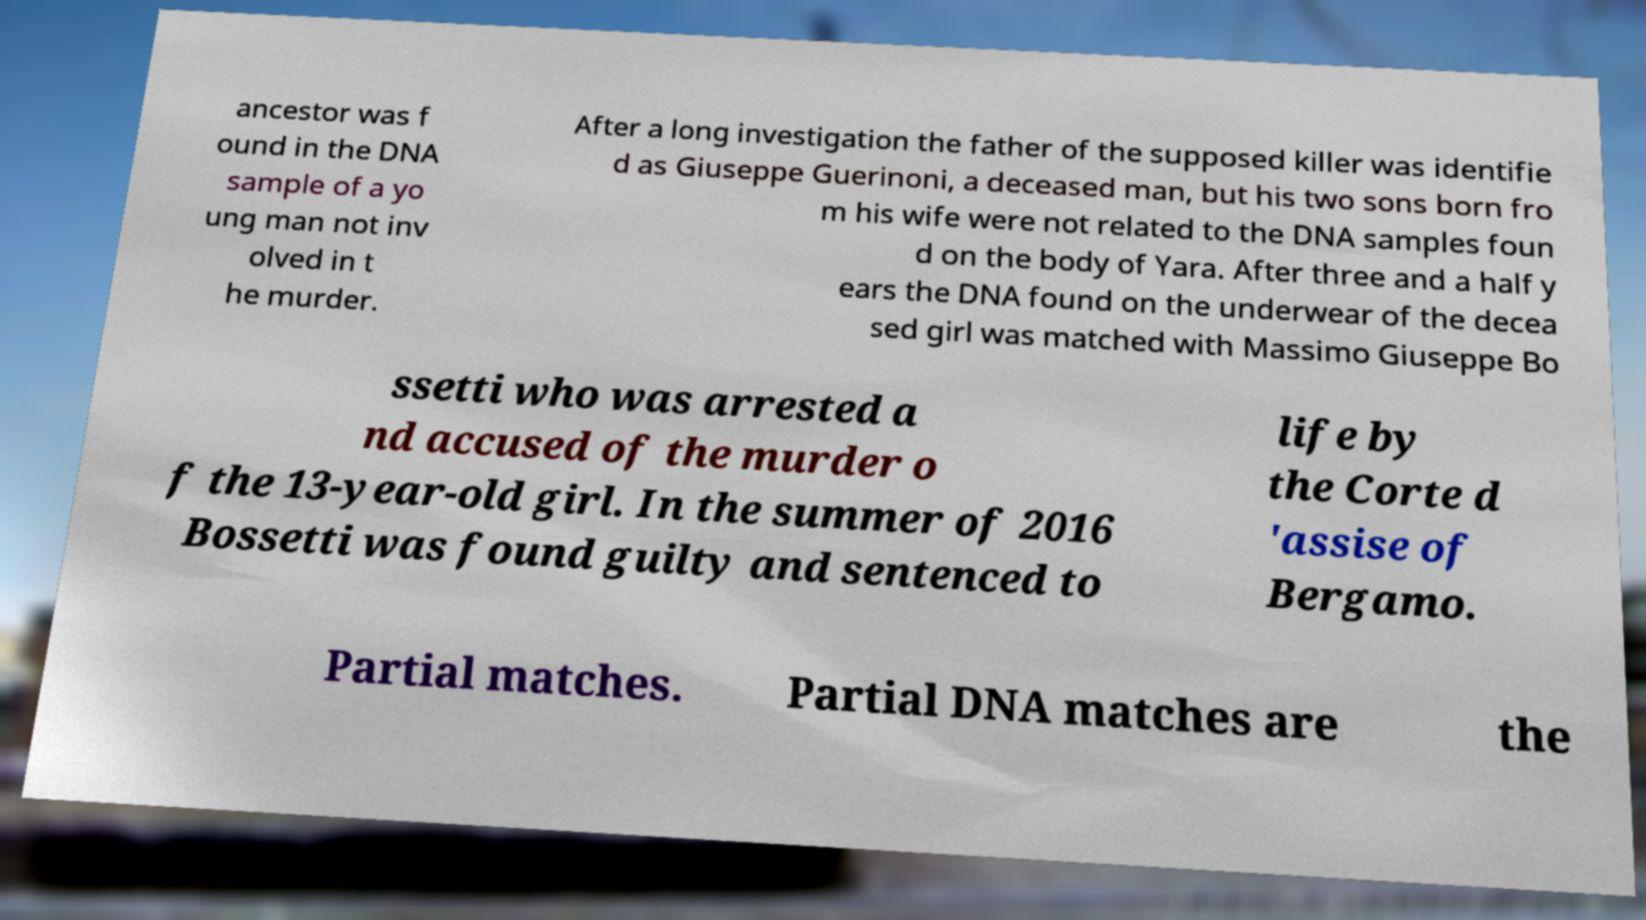Could you extract and type out the text from this image? ancestor was f ound in the DNA sample of a yo ung man not inv olved in t he murder. After a long investigation the father of the supposed killer was identifie d as Giuseppe Guerinoni, a deceased man, but his two sons born fro m his wife were not related to the DNA samples foun d on the body of Yara. After three and a half y ears the DNA found on the underwear of the decea sed girl was matched with Massimo Giuseppe Bo ssetti who was arrested a nd accused of the murder o f the 13-year-old girl. In the summer of 2016 Bossetti was found guilty and sentenced to life by the Corte d 'assise of Bergamo. Partial matches. Partial DNA matches are the 